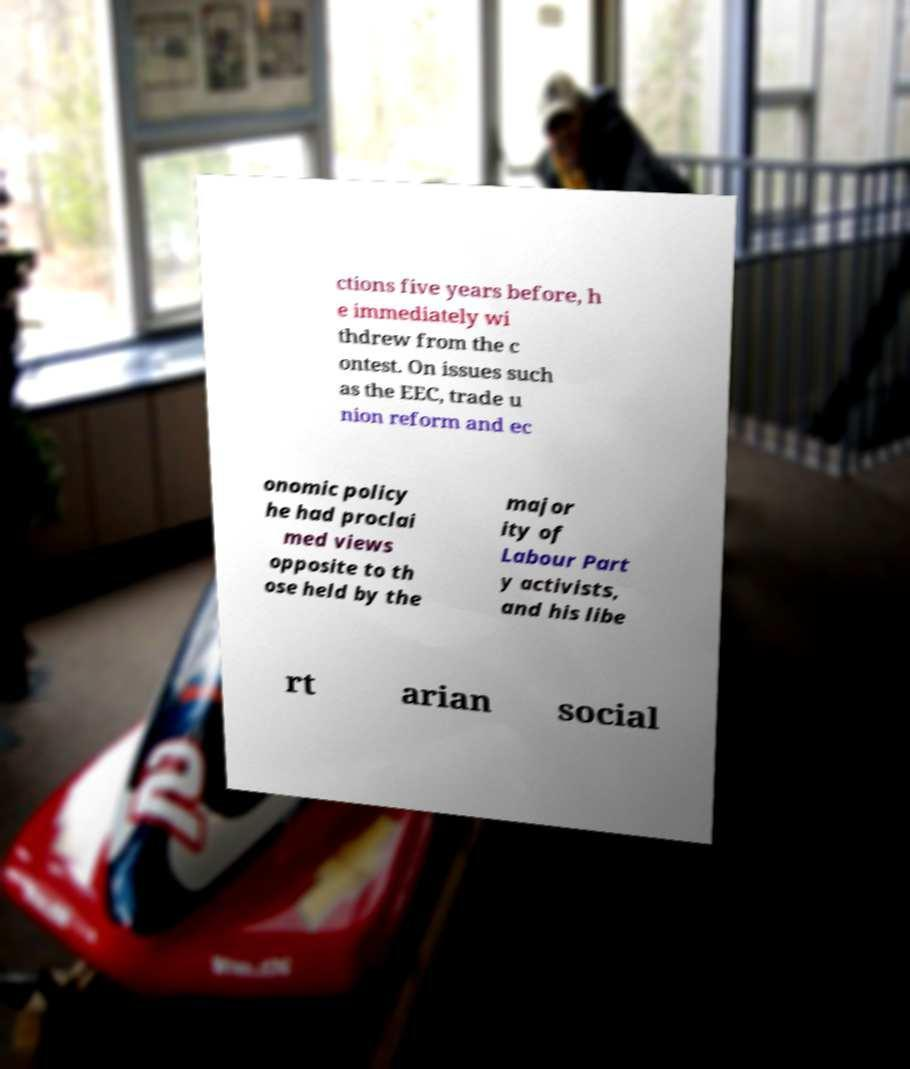For documentation purposes, I need the text within this image transcribed. Could you provide that? ctions five years before, h e immediately wi thdrew from the c ontest. On issues such as the EEC, trade u nion reform and ec onomic policy he had proclai med views opposite to th ose held by the major ity of Labour Part y activists, and his libe rt arian social 